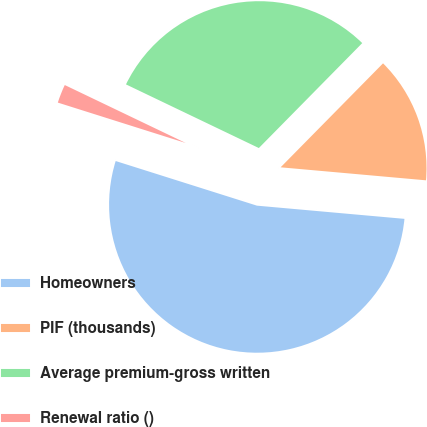<chart> <loc_0><loc_0><loc_500><loc_500><pie_chart><fcel>Homeowners<fcel>PIF (thousands)<fcel>Average premium-gross written<fcel>Renewal ratio ()<nl><fcel>53.45%<fcel>14.04%<fcel>30.27%<fcel>2.24%<nl></chart> 